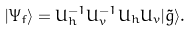Convert formula to latex. <formula><loc_0><loc_0><loc_500><loc_500>| \Psi _ { f } \rangle = U _ { h } ^ { - 1 } U _ { v } ^ { - 1 } U _ { h } U _ { v } | \tilde { g } \rangle .</formula> 